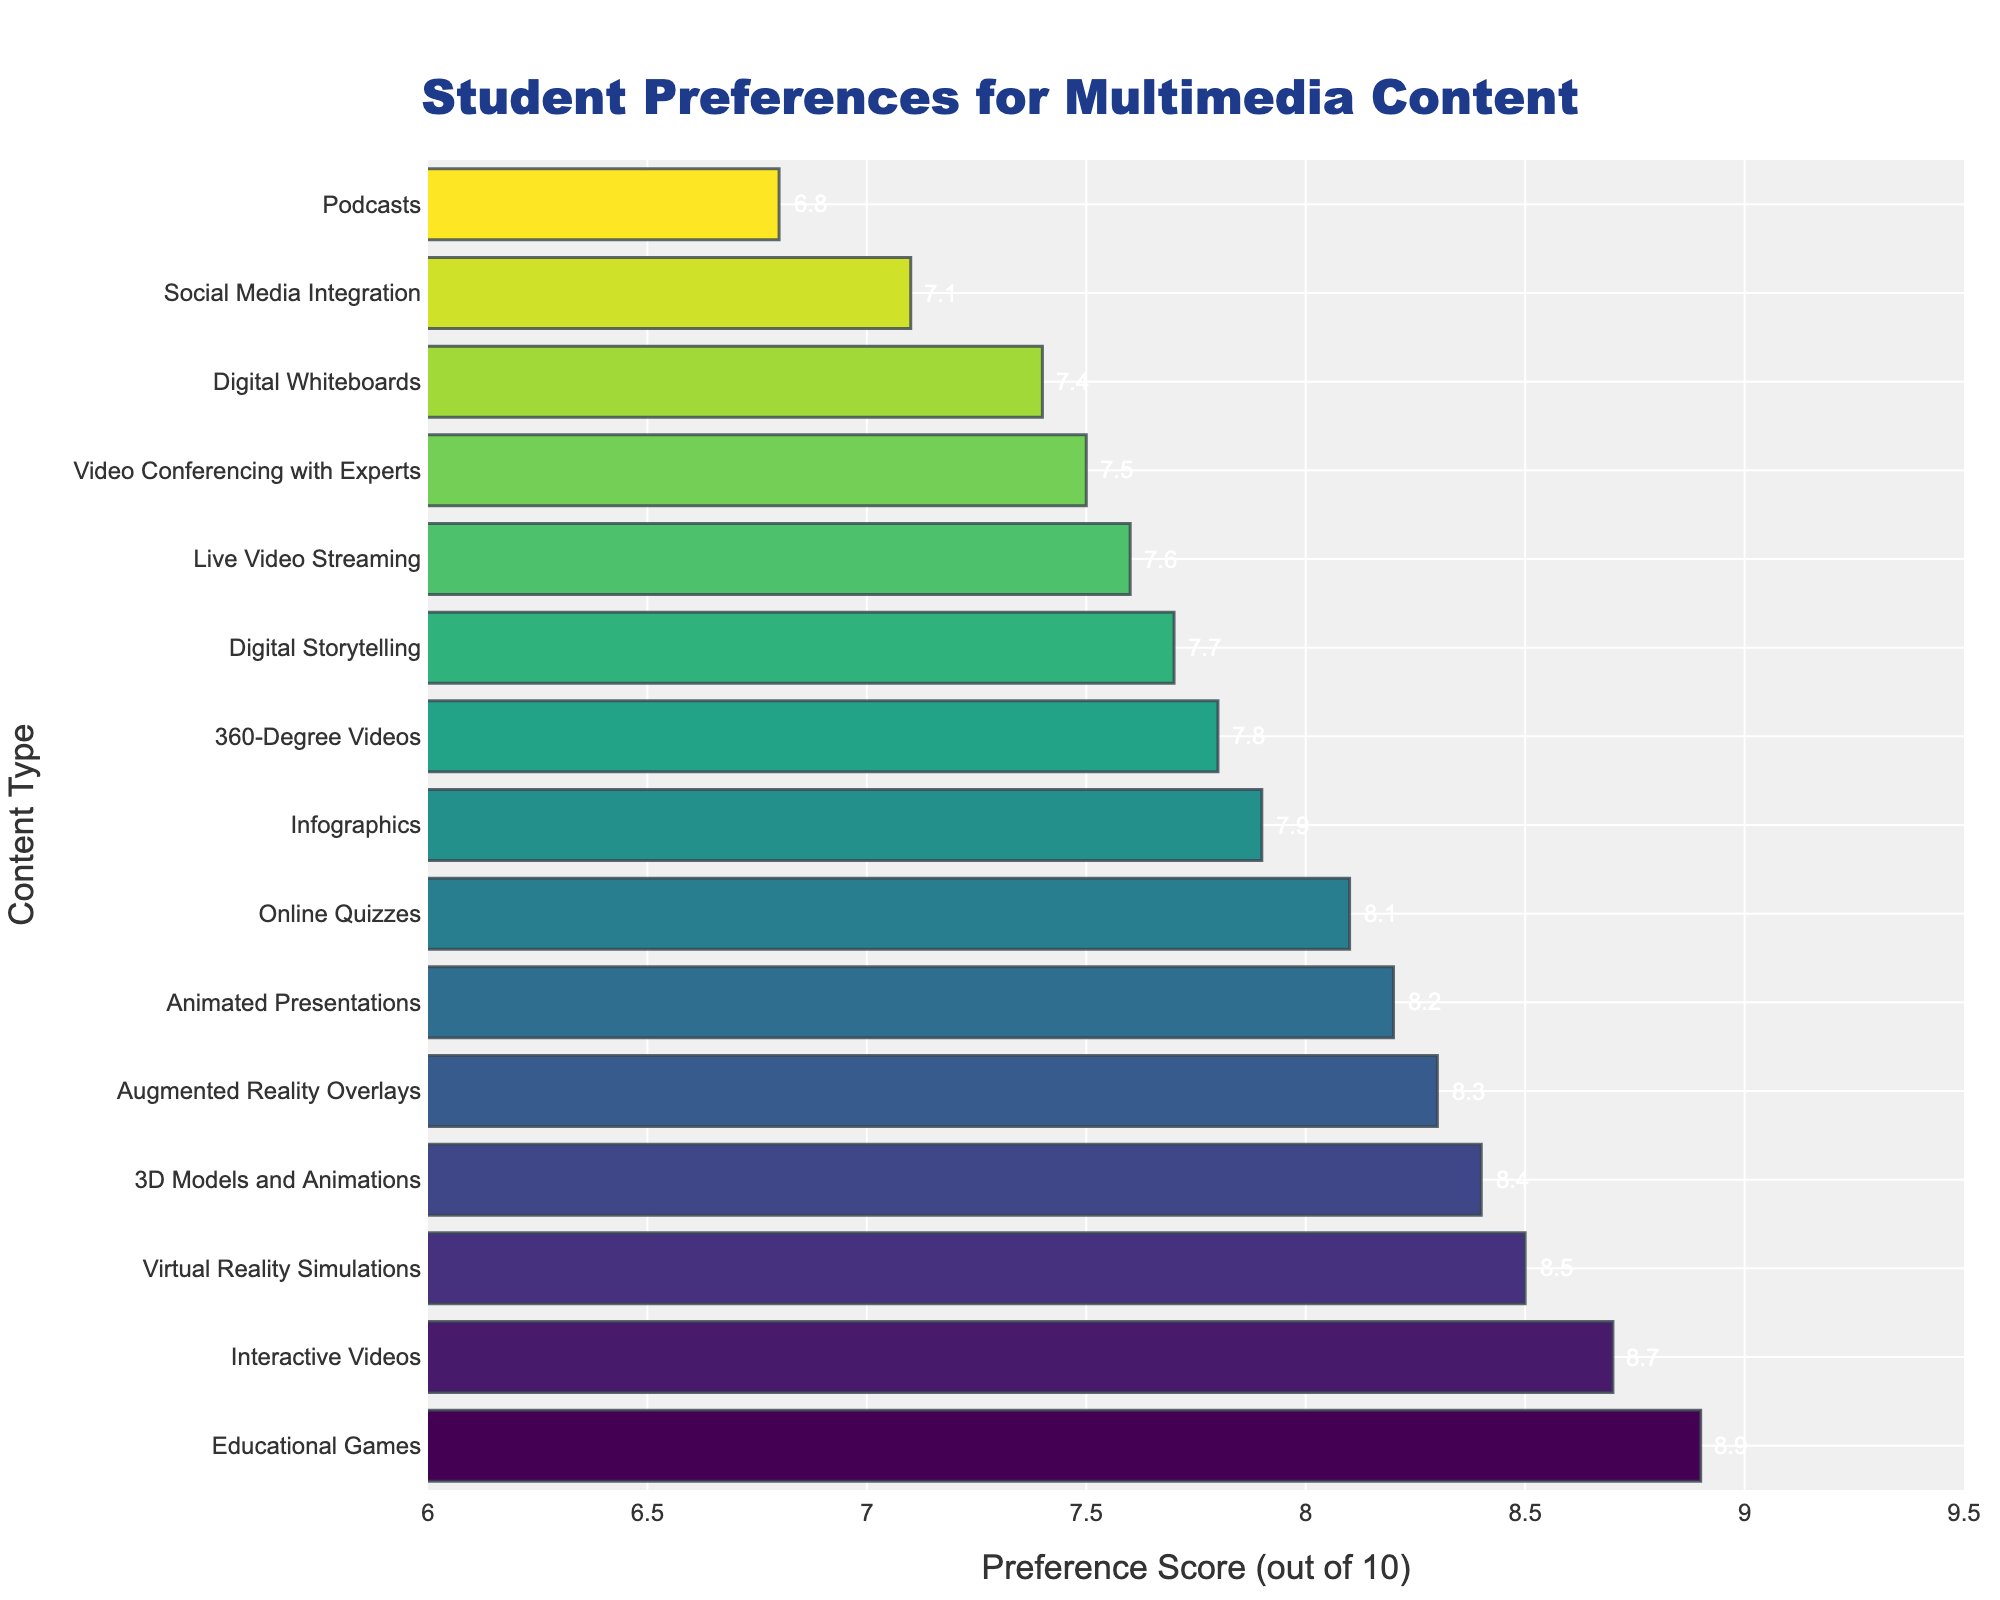Which type of multimedia content is the most preferred among students? According to the bar chart, the highest preference score is for "Educational Games" with a score of 8.9.
Answer: Educational Games What are the two least preferred types of multimedia content based on the preference scores? By looking at the smallest bars on the chart, we see that "Podcasts" and "Social Media Integration" have the lowest scores of 6.8 and 7.1 respectively.
Answer: Podcasts and Social Media Integration How much higher is the preference score for "Interactive Videos" compared to "Digital Whiteboards"? The preference score for "Interactive Videos" is 8.7, and for "Digital Whiteboards" is 7.4. The difference is 8.7 - 7.4 = 1.3.
Answer: 1.3 Which content type has a preference score closest to 8.0? "Animated Presentations" has a score of 8.2, which is closest to 8.0 among all the listed content types.
Answer: Animated Presentations Is the preference score for "Virtual Reality Simulations" greater than that for "3D Models and Animations"? The preference score for "Virtual Reality Simulations" is 8.5, and for "3D Models and Animations" it is 8.4. So, yes, it is greater.
Answer: Yes What is the sum of the preference scores of "Live Video Streaming," "Podcasts," and "Video Conferencing with Experts"? The scores are "Live Video Streaming" 7.6, "Podcasts" 6.8, and "Video Conferencing with Experts" 7.5. Sum = 7.6 + 6.8 + 7.5 = 21.9.
Answer: 21.9 How many content types have a preference score higher than 8? By reviewing the bars with scores over 8, we find "Interactive Videos," "Virtual Reality Simulations," "Animated Presentations," "Educational Games," "Augmented Reality Overlays," "Online Quizzes," and "3D Models and Animations." This counts to seven.
Answer: 7 Which has a longer bar: "Infographics" or "360-Degree Videos"? The bar for "Infographics" has a preference score of 7.9, whereas "360-Degree Videos" has a score of 7.8. Therefore, the bar for "Infographics" is longer.
Answer: Infographics What is the average preference score for the content types listed? Add all preference scores and then divide by the number of content types: (8.7+7.9+8.5+8.2+7.6+8.9+6.8+7.4+8.3+7.8+7.1+8.1+7.5+7.7+8.4)/15 = 8.00
Answer: 8.0 